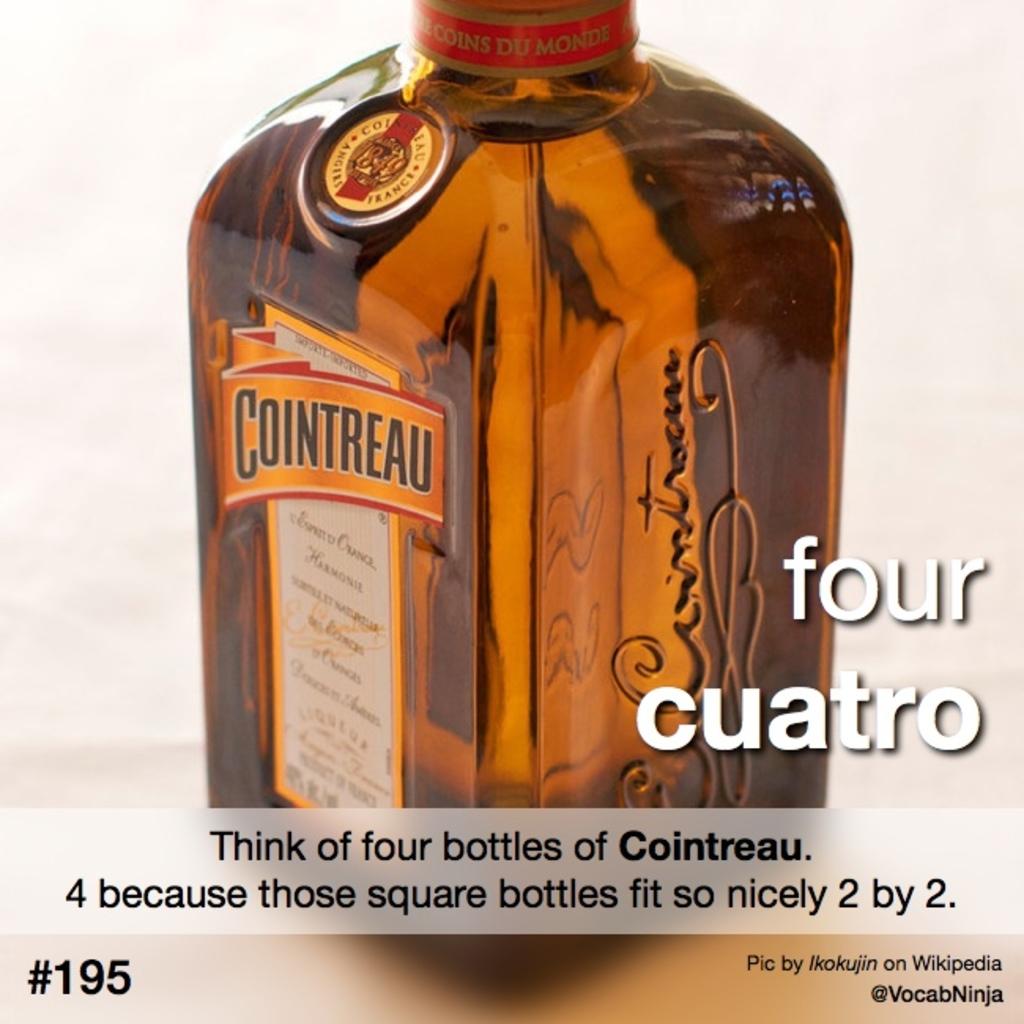How many bottles fit nicely 2 by 2?
Your answer should be very brief. 4. What is the brand of alchohol?
Offer a terse response. Cointreau. 